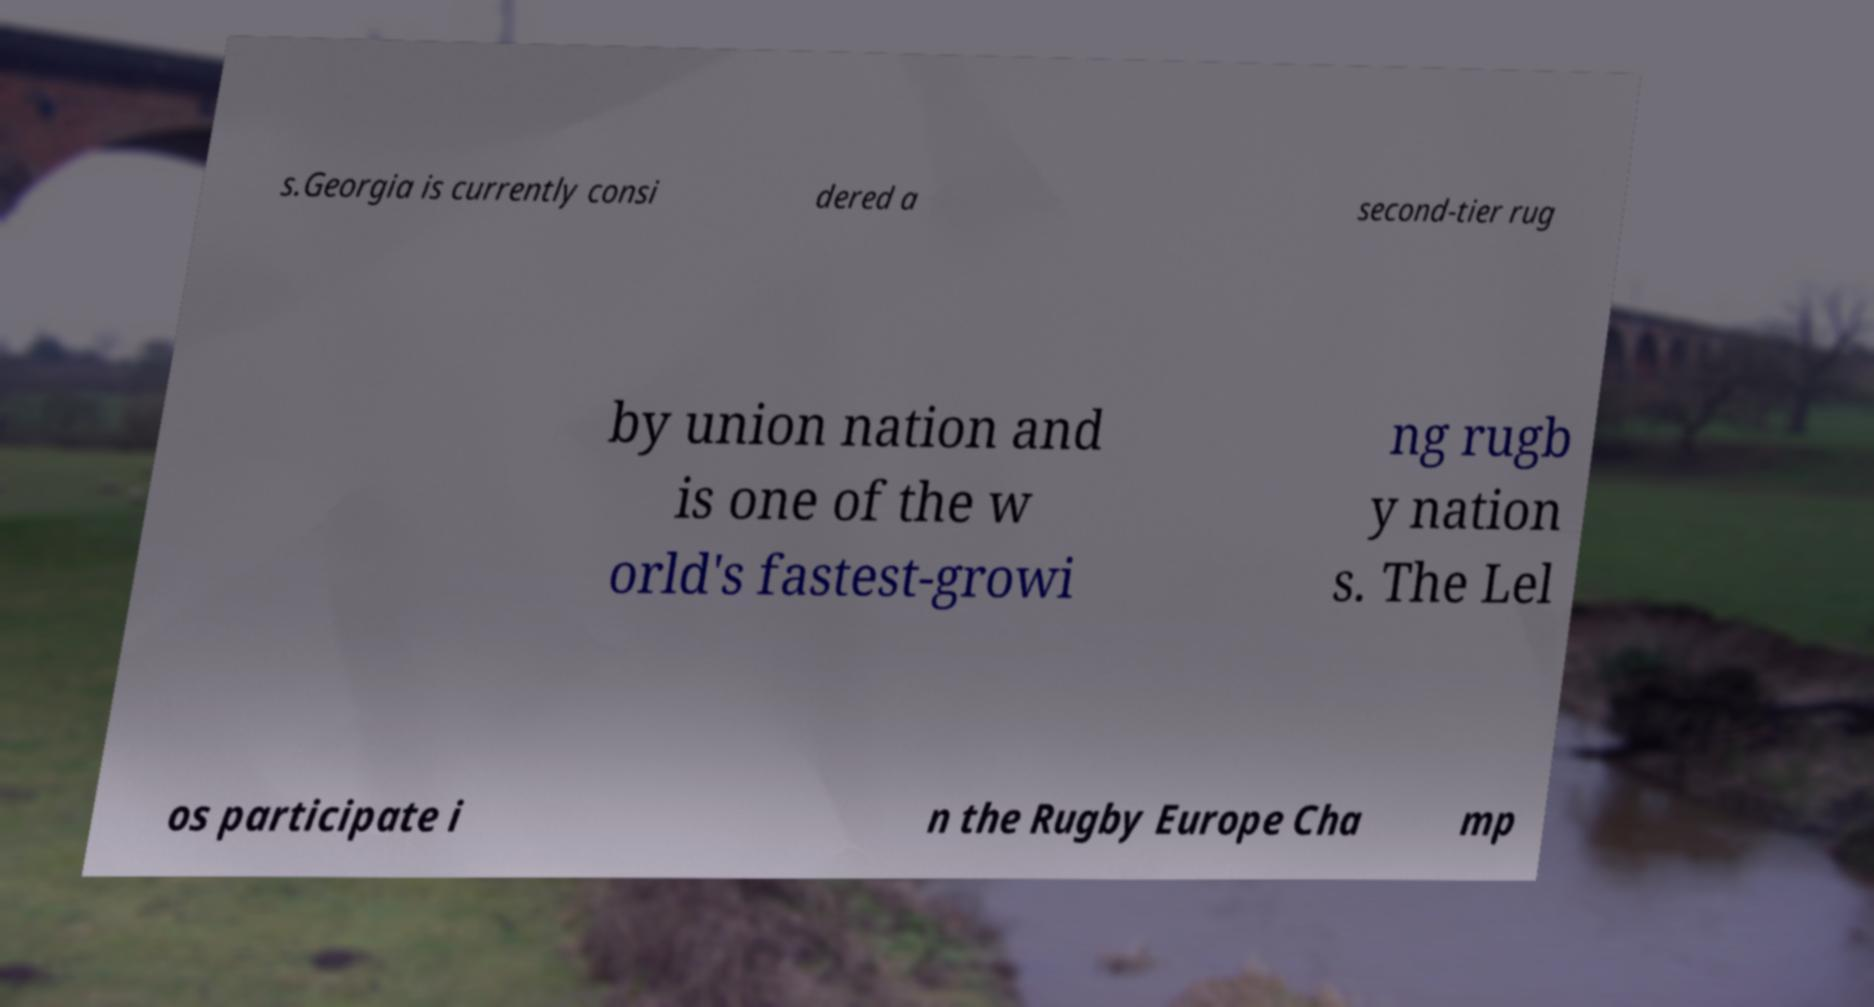Can you read and provide the text displayed in the image?This photo seems to have some interesting text. Can you extract and type it out for me? s.Georgia is currently consi dered a second-tier rug by union nation and is one of the w orld's fastest-growi ng rugb y nation s. The Lel os participate i n the Rugby Europe Cha mp 